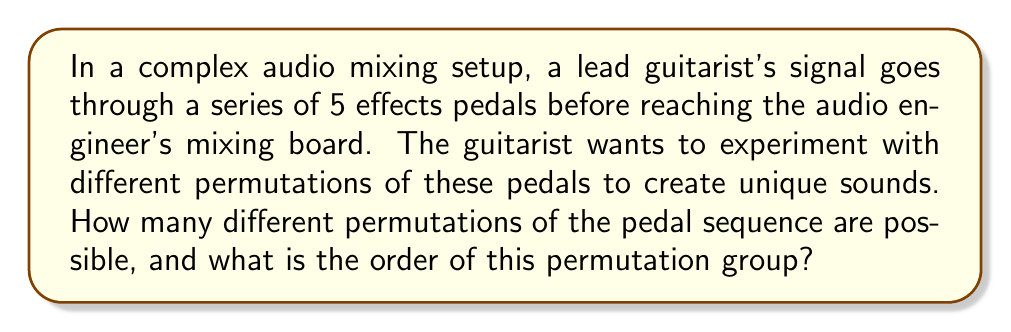Solve this math problem. To solve this problem, we need to understand the concept of permutations in abstract algebra:

1) In this case, we have 5 distinct pedals that can be arranged in any order. This is a perfect scenario for permutations.

2) The number of permutations of n distinct objects is given by n!, where n is the number of objects.

3) In this case, n = 5 (the number of pedals).

4) Therefore, the number of possible permutations is:

   $$5! = 5 \times 4 \times 3 \times 2 \times 1 = 120$$

5) In group theory, these permutations form a symmetric group, often denoted as $S_5$.

6) The order of a group is the number of elements in the group. In this case, the order of the permutation group is equal to the number of permutations.

7) Therefore, the order of this permutation group is also 120.

This means the lead guitarist has 120 different ways to arrange the pedals, each potentially creating a unique sound for the audio engineer to work with.
Answer: The number of possible permutations is 120, and the order of the permutation group is also 120. 